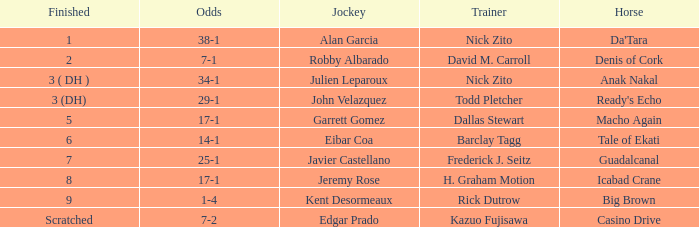What are the Odds for Trainer Barclay Tagg? 14-1. 